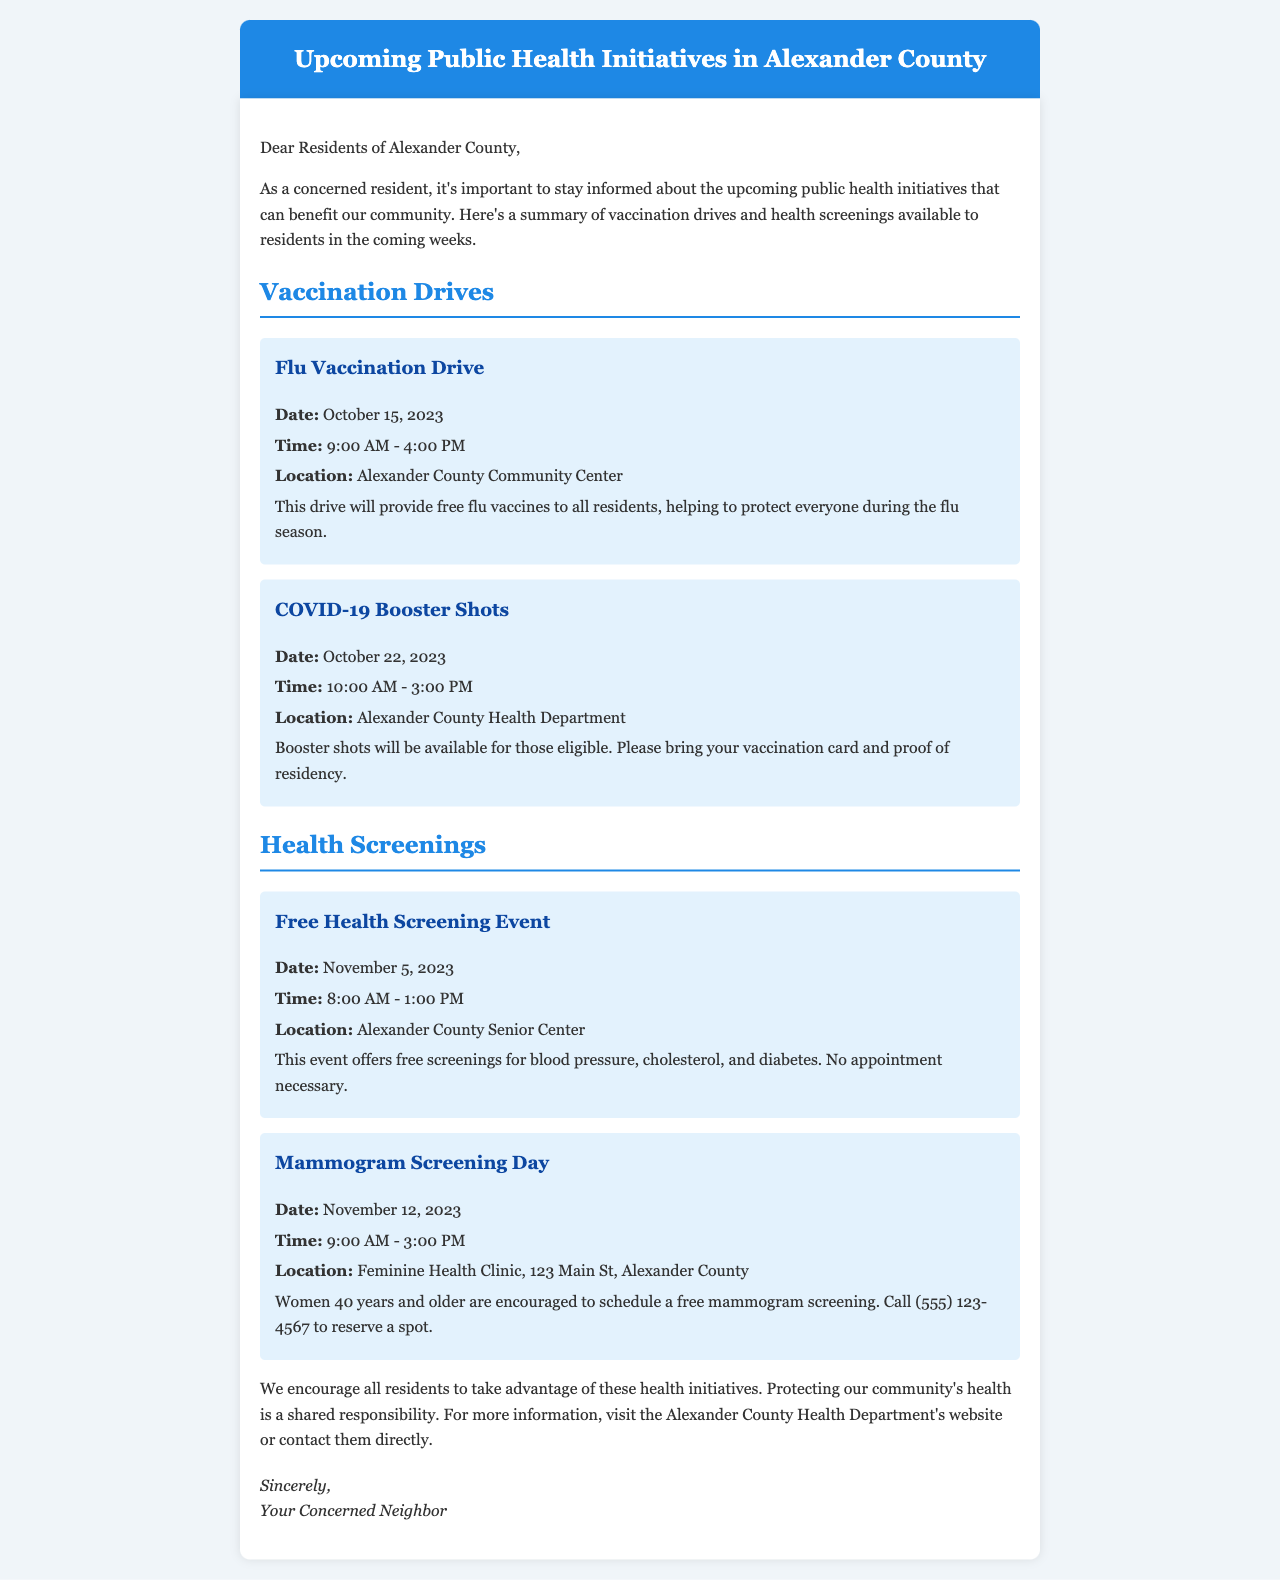What is the date of the Flu Vaccination Drive? The date of the Flu Vaccination Drive is mentioned in the document, which states it will be held on October 15, 2023.
Answer: October 15, 2023 What time will the COVID-19 Booster Shots be available? The document specifies that the COVID-19 Booster Shots will be available from 10:00 AM to 3:00 PM.
Answer: 10:00 AM - 3:00 PM Where will the Free Health Screening Event take place? The location for the Free Health Screening Event is provided in the document, which is at the Alexander County Senior Center.
Answer: Alexander County Senior Center How many health screenings are offered at the Free Health Screening Event? The document lists three specific screenings (blood pressure, cholesterol, diabetes) that will be provided, making it clear how many are offered.
Answer: Three What is required for receiving a COVID-19 Booster Shot? The document states that residents need to bring their vaccination card and proof of residency to receive the shot.
Answer: Vaccination card and proof of residency Why is it important for residents to participate in health initiatives? The document explains that participating in health initiatives is important for protecting the community's health, emphasizing shared responsibility.
Answer: Protecting community health How can residents reserve a spot for the Mammogram Screening Day? The document specifies that residents need to call a provided phone number to reserve a spot for the mammogram screening.
Answer: Call (555) 123-4567 What type of document is this email classified as? This document falls under the category of emails aimed at informing residents about upcoming public health initiatives.
Answer: Informational email What is the purpose of the upcoming initiatives mentioned in the document? The purpose of the initiatives is to offer vaccination drives and health screenings to benefit the community's health.
Answer: Benefit community health 